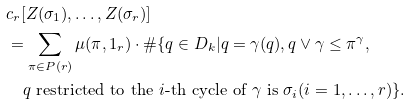Convert formula to latex. <formula><loc_0><loc_0><loc_500><loc_500>& c _ { r } [ Z ( \sigma _ { 1 } ) , \dots , Z ( \sigma _ { r } ) ] \\ & = \sum _ { \pi \in P ( r ) } \mu ( \pi , 1 _ { r } ) \cdot \# \{ q \in D _ { k } | q = \gamma ( q ) , q \vee \gamma \leq \pi ^ { \gamma } , \\ & \quad \text {$q$ restricted to the $i$-th cycle of $\gamma$ is $\sigma_{i}$} ( i = 1 , \dots , r ) \} .</formula> 